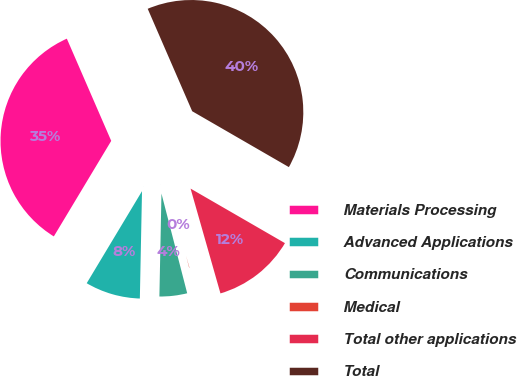<chart> <loc_0><loc_0><loc_500><loc_500><pie_chart><fcel>Materials Processing<fcel>Advanced Applications<fcel>Communications<fcel>Medical<fcel>Total other applications<fcel>Total<nl><fcel>34.87%<fcel>8.29%<fcel>4.34%<fcel>0.4%<fcel>12.24%<fcel>39.86%<nl></chart> 